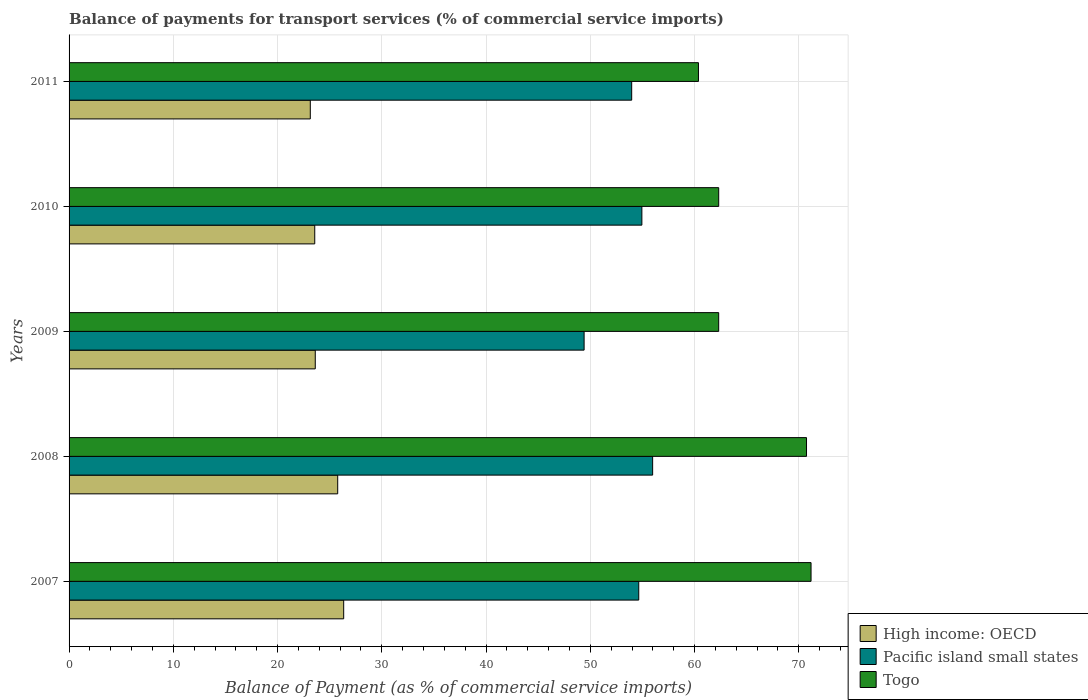How many different coloured bars are there?
Offer a very short reply. 3. Are the number of bars per tick equal to the number of legend labels?
Offer a very short reply. Yes. In how many cases, is the number of bars for a given year not equal to the number of legend labels?
Ensure brevity in your answer.  0. What is the balance of payments for transport services in Togo in 2009?
Your response must be concise. 62.31. Across all years, what is the maximum balance of payments for transport services in High income: OECD?
Make the answer very short. 26.34. Across all years, what is the minimum balance of payments for transport services in High income: OECD?
Provide a short and direct response. 23.14. In which year was the balance of payments for transport services in High income: OECD maximum?
Keep it short and to the point. 2007. In which year was the balance of payments for transport services in Togo minimum?
Make the answer very short. 2011. What is the total balance of payments for transport services in Togo in the graph?
Offer a terse response. 326.91. What is the difference between the balance of payments for transport services in Togo in 2008 and that in 2011?
Provide a succinct answer. 10.37. What is the difference between the balance of payments for transport services in Togo in 2009 and the balance of payments for transport services in Pacific island small states in 2007?
Make the answer very short. 7.67. What is the average balance of payments for transport services in High income: OECD per year?
Your answer should be very brief. 24.49. In the year 2008, what is the difference between the balance of payments for transport services in High income: OECD and balance of payments for transport services in Togo?
Provide a short and direct response. -44.97. What is the ratio of the balance of payments for transport services in Pacific island small states in 2008 to that in 2009?
Give a very brief answer. 1.13. Is the balance of payments for transport services in Pacific island small states in 2008 less than that in 2011?
Offer a very short reply. No. Is the difference between the balance of payments for transport services in High income: OECD in 2009 and 2010 greater than the difference between the balance of payments for transport services in Togo in 2009 and 2010?
Offer a terse response. Yes. What is the difference between the highest and the second highest balance of payments for transport services in Pacific island small states?
Offer a very short reply. 1.03. What is the difference between the highest and the lowest balance of payments for transport services in Togo?
Your answer should be compact. 10.8. In how many years, is the balance of payments for transport services in High income: OECD greater than the average balance of payments for transport services in High income: OECD taken over all years?
Keep it short and to the point. 2. What does the 1st bar from the top in 2008 represents?
Give a very brief answer. Togo. What does the 3rd bar from the bottom in 2007 represents?
Provide a short and direct response. Togo. Is it the case that in every year, the sum of the balance of payments for transport services in High income: OECD and balance of payments for transport services in Pacific island small states is greater than the balance of payments for transport services in Togo?
Offer a very short reply. Yes. How many bars are there?
Your response must be concise. 15. Are all the bars in the graph horizontal?
Give a very brief answer. Yes. Does the graph contain any zero values?
Provide a short and direct response. No. Where does the legend appear in the graph?
Your response must be concise. Bottom right. How many legend labels are there?
Offer a very short reply. 3. What is the title of the graph?
Your answer should be compact. Balance of payments for transport services (% of commercial service imports). What is the label or title of the X-axis?
Provide a short and direct response. Balance of Payment (as % of commercial service imports). What is the label or title of the Y-axis?
Your answer should be compact. Years. What is the Balance of Payment (as % of commercial service imports) in High income: OECD in 2007?
Keep it short and to the point. 26.34. What is the Balance of Payment (as % of commercial service imports) in Pacific island small states in 2007?
Ensure brevity in your answer.  54.64. What is the Balance of Payment (as % of commercial service imports) in Togo in 2007?
Provide a short and direct response. 71.17. What is the Balance of Payment (as % of commercial service imports) in High income: OECD in 2008?
Your answer should be compact. 25.77. What is the Balance of Payment (as % of commercial service imports) in Pacific island small states in 2008?
Your response must be concise. 55.98. What is the Balance of Payment (as % of commercial service imports) of Togo in 2008?
Offer a very short reply. 70.74. What is the Balance of Payment (as % of commercial service imports) of High income: OECD in 2009?
Ensure brevity in your answer.  23.62. What is the Balance of Payment (as % of commercial service imports) of Pacific island small states in 2009?
Ensure brevity in your answer.  49.4. What is the Balance of Payment (as % of commercial service imports) in Togo in 2009?
Your answer should be very brief. 62.31. What is the Balance of Payment (as % of commercial service imports) of High income: OECD in 2010?
Your response must be concise. 23.57. What is the Balance of Payment (as % of commercial service imports) of Pacific island small states in 2010?
Your response must be concise. 54.94. What is the Balance of Payment (as % of commercial service imports) of Togo in 2010?
Your answer should be compact. 62.31. What is the Balance of Payment (as % of commercial service imports) of High income: OECD in 2011?
Give a very brief answer. 23.14. What is the Balance of Payment (as % of commercial service imports) in Pacific island small states in 2011?
Your answer should be very brief. 53.97. What is the Balance of Payment (as % of commercial service imports) in Togo in 2011?
Your answer should be compact. 60.37. Across all years, what is the maximum Balance of Payment (as % of commercial service imports) of High income: OECD?
Your response must be concise. 26.34. Across all years, what is the maximum Balance of Payment (as % of commercial service imports) in Pacific island small states?
Provide a short and direct response. 55.98. Across all years, what is the maximum Balance of Payment (as % of commercial service imports) of Togo?
Provide a short and direct response. 71.17. Across all years, what is the minimum Balance of Payment (as % of commercial service imports) of High income: OECD?
Keep it short and to the point. 23.14. Across all years, what is the minimum Balance of Payment (as % of commercial service imports) of Pacific island small states?
Ensure brevity in your answer.  49.4. Across all years, what is the minimum Balance of Payment (as % of commercial service imports) in Togo?
Provide a short and direct response. 60.37. What is the total Balance of Payment (as % of commercial service imports) of High income: OECD in the graph?
Provide a succinct answer. 122.43. What is the total Balance of Payment (as % of commercial service imports) in Pacific island small states in the graph?
Make the answer very short. 268.93. What is the total Balance of Payment (as % of commercial service imports) in Togo in the graph?
Your response must be concise. 326.91. What is the difference between the Balance of Payment (as % of commercial service imports) in High income: OECD in 2007 and that in 2008?
Make the answer very short. 0.57. What is the difference between the Balance of Payment (as % of commercial service imports) of Pacific island small states in 2007 and that in 2008?
Provide a short and direct response. -1.33. What is the difference between the Balance of Payment (as % of commercial service imports) of Togo in 2007 and that in 2008?
Offer a terse response. 0.43. What is the difference between the Balance of Payment (as % of commercial service imports) of High income: OECD in 2007 and that in 2009?
Give a very brief answer. 2.73. What is the difference between the Balance of Payment (as % of commercial service imports) of Pacific island small states in 2007 and that in 2009?
Ensure brevity in your answer.  5.24. What is the difference between the Balance of Payment (as % of commercial service imports) in Togo in 2007 and that in 2009?
Keep it short and to the point. 8.86. What is the difference between the Balance of Payment (as % of commercial service imports) in High income: OECD in 2007 and that in 2010?
Your answer should be very brief. 2.77. What is the difference between the Balance of Payment (as % of commercial service imports) in Pacific island small states in 2007 and that in 2010?
Your response must be concise. -0.3. What is the difference between the Balance of Payment (as % of commercial service imports) in Togo in 2007 and that in 2010?
Your response must be concise. 8.86. What is the difference between the Balance of Payment (as % of commercial service imports) of High income: OECD in 2007 and that in 2011?
Keep it short and to the point. 3.2. What is the difference between the Balance of Payment (as % of commercial service imports) in Pacific island small states in 2007 and that in 2011?
Your answer should be compact. 0.68. What is the difference between the Balance of Payment (as % of commercial service imports) in Togo in 2007 and that in 2011?
Make the answer very short. 10.8. What is the difference between the Balance of Payment (as % of commercial service imports) in High income: OECD in 2008 and that in 2009?
Your answer should be very brief. 2.15. What is the difference between the Balance of Payment (as % of commercial service imports) in Pacific island small states in 2008 and that in 2009?
Provide a short and direct response. 6.57. What is the difference between the Balance of Payment (as % of commercial service imports) of Togo in 2008 and that in 2009?
Give a very brief answer. 8.42. What is the difference between the Balance of Payment (as % of commercial service imports) in High income: OECD in 2008 and that in 2010?
Make the answer very short. 2.2. What is the difference between the Balance of Payment (as % of commercial service imports) in Pacific island small states in 2008 and that in 2010?
Provide a short and direct response. 1.03. What is the difference between the Balance of Payment (as % of commercial service imports) of Togo in 2008 and that in 2010?
Keep it short and to the point. 8.42. What is the difference between the Balance of Payment (as % of commercial service imports) of High income: OECD in 2008 and that in 2011?
Provide a short and direct response. 2.63. What is the difference between the Balance of Payment (as % of commercial service imports) in Pacific island small states in 2008 and that in 2011?
Your answer should be very brief. 2.01. What is the difference between the Balance of Payment (as % of commercial service imports) of Togo in 2008 and that in 2011?
Offer a very short reply. 10.37. What is the difference between the Balance of Payment (as % of commercial service imports) of High income: OECD in 2009 and that in 2010?
Keep it short and to the point. 0.05. What is the difference between the Balance of Payment (as % of commercial service imports) in Pacific island small states in 2009 and that in 2010?
Keep it short and to the point. -5.54. What is the difference between the Balance of Payment (as % of commercial service imports) in Togo in 2009 and that in 2010?
Offer a very short reply. -0. What is the difference between the Balance of Payment (as % of commercial service imports) in High income: OECD in 2009 and that in 2011?
Provide a succinct answer. 0.48. What is the difference between the Balance of Payment (as % of commercial service imports) of Pacific island small states in 2009 and that in 2011?
Give a very brief answer. -4.56. What is the difference between the Balance of Payment (as % of commercial service imports) in Togo in 2009 and that in 2011?
Your response must be concise. 1.94. What is the difference between the Balance of Payment (as % of commercial service imports) in High income: OECD in 2010 and that in 2011?
Make the answer very short. 0.43. What is the difference between the Balance of Payment (as % of commercial service imports) of Pacific island small states in 2010 and that in 2011?
Your answer should be compact. 0.98. What is the difference between the Balance of Payment (as % of commercial service imports) in Togo in 2010 and that in 2011?
Ensure brevity in your answer.  1.94. What is the difference between the Balance of Payment (as % of commercial service imports) of High income: OECD in 2007 and the Balance of Payment (as % of commercial service imports) of Pacific island small states in 2008?
Keep it short and to the point. -29.64. What is the difference between the Balance of Payment (as % of commercial service imports) of High income: OECD in 2007 and the Balance of Payment (as % of commercial service imports) of Togo in 2008?
Keep it short and to the point. -44.4. What is the difference between the Balance of Payment (as % of commercial service imports) of Pacific island small states in 2007 and the Balance of Payment (as % of commercial service imports) of Togo in 2008?
Provide a short and direct response. -16.09. What is the difference between the Balance of Payment (as % of commercial service imports) of High income: OECD in 2007 and the Balance of Payment (as % of commercial service imports) of Pacific island small states in 2009?
Offer a very short reply. -23.06. What is the difference between the Balance of Payment (as % of commercial service imports) in High income: OECD in 2007 and the Balance of Payment (as % of commercial service imports) in Togo in 2009?
Ensure brevity in your answer.  -35.97. What is the difference between the Balance of Payment (as % of commercial service imports) in Pacific island small states in 2007 and the Balance of Payment (as % of commercial service imports) in Togo in 2009?
Make the answer very short. -7.67. What is the difference between the Balance of Payment (as % of commercial service imports) of High income: OECD in 2007 and the Balance of Payment (as % of commercial service imports) of Pacific island small states in 2010?
Give a very brief answer. -28.6. What is the difference between the Balance of Payment (as % of commercial service imports) in High income: OECD in 2007 and the Balance of Payment (as % of commercial service imports) in Togo in 2010?
Make the answer very short. -35.97. What is the difference between the Balance of Payment (as % of commercial service imports) in Pacific island small states in 2007 and the Balance of Payment (as % of commercial service imports) in Togo in 2010?
Ensure brevity in your answer.  -7.67. What is the difference between the Balance of Payment (as % of commercial service imports) of High income: OECD in 2007 and the Balance of Payment (as % of commercial service imports) of Pacific island small states in 2011?
Make the answer very short. -27.63. What is the difference between the Balance of Payment (as % of commercial service imports) in High income: OECD in 2007 and the Balance of Payment (as % of commercial service imports) in Togo in 2011?
Provide a short and direct response. -34.03. What is the difference between the Balance of Payment (as % of commercial service imports) of Pacific island small states in 2007 and the Balance of Payment (as % of commercial service imports) of Togo in 2011?
Your response must be concise. -5.73. What is the difference between the Balance of Payment (as % of commercial service imports) of High income: OECD in 2008 and the Balance of Payment (as % of commercial service imports) of Pacific island small states in 2009?
Offer a terse response. -23.64. What is the difference between the Balance of Payment (as % of commercial service imports) in High income: OECD in 2008 and the Balance of Payment (as % of commercial service imports) in Togo in 2009?
Your answer should be compact. -36.55. What is the difference between the Balance of Payment (as % of commercial service imports) of Pacific island small states in 2008 and the Balance of Payment (as % of commercial service imports) of Togo in 2009?
Your answer should be compact. -6.34. What is the difference between the Balance of Payment (as % of commercial service imports) in High income: OECD in 2008 and the Balance of Payment (as % of commercial service imports) in Pacific island small states in 2010?
Ensure brevity in your answer.  -29.18. What is the difference between the Balance of Payment (as % of commercial service imports) in High income: OECD in 2008 and the Balance of Payment (as % of commercial service imports) in Togo in 2010?
Your response must be concise. -36.55. What is the difference between the Balance of Payment (as % of commercial service imports) of Pacific island small states in 2008 and the Balance of Payment (as % of commercial service imports) of Togo in 2010?
Offer a very short reply. -6.34. What is the difference between the Balance of Payment (as % of commercial service imports) in High income: OECD in 2008 and the Balance of Payment (as % of commercial service imports) in Pacific island small states in 2011?
Offer a terse response. -28.2. What is the difference between the Balance of Payment (as % of commercial service imports) of High income: OECD in 2008 and the Balance of Payment (as % of commercial service imports) of Togo in 2011?
Keep it short and to the point. -34.6. What is the difference between the Balance of Payment (as % of commercial service imports) in Pacific island small states in 2008 and the Balance of Payment (as % of commercial service imports) in Togo in 2011?
Provide a succinct answer. -4.4. What is the difference between the Balance of Payment (as % of commercial service imports) of High income: OECD in 2009 and the Balance of Payment (as % of commercial service imports) of Pacific island small states in 2010?
Provide a succinct answer. -31.33. What is the difference between the Balance of Payment (as % of commercial service imports) of High income: OECD in 2009 and the Balance of Payment (as % of commercial service imports) of Togo in 2010?
Your answer should be compact. -38.7. What is the difference between the Balance of Payment (as % of commercial service imports) of Pacific island small states in 2009 and the Balance of Payment (as % of commercial service imports) of Togo in 2010?
Provide a short and direct response. -12.91. What is the difference between the Balance of Payment (as % of commercial service imports) of High income: OECD in 2009 and the Balance of Payment (as % of commercial service imports) of Pacific island small states in 2011?
Your response must be concise. -30.35. What is the difference between the Balance of Payment (as % of commercial service imports) in High income: OECD in 2009 and the Balance of Payment (as % of commercial service imports) in Togo in 2011?
Offer a very short reply. -36.76. What is the difference between the Balance of Payment (as % of commercial service imports) in Pacific island small states in 2009 and the Balance of Payment (as % of commercial service imports) in Togo in 2011?
Ensure brevity in your answer.  -10.97. What is the difference between the Balance of Payment (as % of commercial service imports) of High income: OECD in 2010 and the Balance of Payment (as % of commercial service imports) of Pacific island small states in 2011?
Provide a succinct answer. -30.4. What is the difference between the Balance of Payment (as % of commercial service imports) of High income: OECD in 2010 and the Balance of Payment (as % of commercial service imports) of Togo in 2011?
Offer a terse response. -36.81. What is the difference between the Balance of Payment (as % of commercial service imports) of Pacific island small states in 2010 and the Balance of Payment (as % of commercial service imports) of Togo in 2011?
Ensure brevity in your answer.  -5.43. What is the average Balance of Payment (as % of commercial service imports) of High income: OECD per year?
Ensure brevity in your answer.  24.49. What is the average Balance of Payment (as % of commercial service imports) in Pacific island small states per year?
Offer a very short reply. 53.79. What is the average Balance of Payment (as % of commercial service imports) of Togo per year?
Give a very brief answer. 65.38. In the year 2007, what is the difference between the Balance of Payment (as % of commercial service imports) in High income: OECD and Balance of Payment (as % of commercial service imports) in Pacific island small states?
Give a very brief answer. -28.3. In the year 2007, what is the difference between the Balance of Payment (as % of commercial service imports) of High income: OECD and Balance of Payment (as % of commercial service imports) of Togo?
Keep it short and to the point. -44.83. In the year 2007, what is the difference between the Balance of Payment (as % of commercial service imports) of Pacific island small states and Balance of Payment (as % of commercial service imports) of Togo?
Offer a terse response. -16.53. In the year 2008, what is the difference between the Balance of Payment (as % of commercial service imports) in High income: OECD and Balance of Payment (as % of commercial service imports) in Pacific island small states?
Give a very brief answer. -30.21. In the year 2008, what is the difference between the Balance of Payment (as % of commercial service imports) in High income: OECD and Balance of Payment (as % of commercial service imports) in Togo?
Provide a short and direct response. -44.97. In the year 2008, what is the difference between the Balance of Payment (as % of commercial service imports) in Pacific island small states and Balance of Payment (as % of commercial service imports) in Togo?
Offer a terse response. -14.76. In the year 2009, what is the difference between the Balance of Payment (as % of commercial service imports) in High income: OECD and Balance of Payment (as % of commercial service imports) in Pacific island small states?
Give a very brief answer. -25.79. In the year 2009, what is the difference between the Balance of Payment (as % of commercial service imports) of High income: OECD and Balance of Payment (as % of commercial service imports) of Togo?
Provide a short and direct response. -38.7. In the year 2009, what is the difference between the Balance of Payment (as % of commercial service imports) in Pacific island small states and Balance of Payment (as % of commercial service imports) in Togo?
Give a very brief answer. -12.91. In the year 2010, what is the difference between the Balance of Payment (as % of commercial service imports) of High income: OECD and Balance of Payment (as % of commercial service imports) of Pacific island small states?
Give a very brief answer. -31.38. In the year 2010, what is the difference between the Balance of Payment (as % of commercial service imports) of High income: OECD and Balance of Payment (as % of commercial service imports) of Togo?
Keep it short and to the point. -38.75. In the year 2010, what is the difference between the Balance of Payment (as % of commercial service imports) of Pacific island small states and Balance of Payment (as % of commercial service imports) of Togo?
Make the answer very short. -7.37. In the year 2011, what is the difference between the Balance of Payment (as % of commercial service imports) of High income: OECD and Balance of Payment (as % of commercial service imports) of Pacific island small states?
Your answer should be compact. -30.83. In the year 2011, what is the difference between the Balance of Payment (as % of commercial service imports) of High income: OECD and Balance of Payment (as % of commercial service imports) of Togo?
Offer a terse response. -37.23. In the year 2011, what is the difference between the Balance of Payment (as % of commercial service imports) of Pacific island small states and Balance of Payment (as % of commercial service imports) of Togo?
Provide a short and direct response. -6.4. What is the ratio of the Balance of Payment (as % of commercial service imports) in High income: OECD in 2007 to that in 2008?
Make the answer very short. 1.02. What is the ratio of the Balance of Payment (as % of commercial service imports) in Pacific island small states in 2007 to that in 2008?
Offer a very short reply. 0.98. What is the ratio of the Balance of Payment (as % of commercial service imports) in High income: OECD in 2007 to that in 2009?
Provide a succinct answer. 1.12. What is the ratio of the Balance of Payment (as % of commercial service imports) in Pacific island small states in 2007 to that in 2009?
Keep it short and to the point. 1.11. What is the ratio of the Balance of Payment (as % of commercial service imports) of Togo in 2007 to that in 2009?
Your answer should be compact. 1.14. What is the ratio of the Balance of Payment (as % of commercial service imports) of High income: OECD in 2007 to that in 2010?
Your response must be concise. 1.12. What is the ratio of the Balance of Payment (as % of commercial service imports) of Pacific island small states in 2007 to that in 2010?
Give a very brief answer. 0.99. What is the ratio of the Balance of Payment (as % of commercial service imports) of Togo in 2007 to that in 2010?
Keep it short and to the point. 1.14. What is the ratio of the Balance of Payment (as % of commercial service imports) in High income: OECD in 2007 to that in 2011?
Ensure brevity in your answer.  1.14. What is the ratio of the Balance of Payment (as % of commercial service imports) in Pacific island small states in 2007 to that in 2011?
Your answer should be very brief. 1.01. What is the ratio of the Balance of Payment (as % of commercial service imports) in Togo in 2007 to that in 2011?
Make the answer very short. 1.18. What is the ratio of the Balance of Payment (as % of commercial service imports) of High income: OECD in 2008 to that in 2009?
Provide a succinct answer. 1.09. What is the ratio of the Balance of Payment (as % of commercial service imports) of Pacific island small states in 2008 to that in 2009?
Your response must be concise. 1.13. What is the ratio of the Balance of Payment (as % of commercial service imports) in Togo in 2008 to that in 2009?
Provide a short and direct response. 1.14. What is the ratio of the Balance of Payment (as % of commercial service imports) of High income: OECD in 2008 to that in 2010?
Your response must be concise. 1.09. What is the ratio of the Balance of Payment (as % of commercial service imports) of Pacific island small states in 2008 to that in 2010?
Your response must be concise. 1.02. What is the ratio of the Balance of Payment (as % of commercial service imports) of Togo in 2008 to that in 2010?
Ensure brevity in your answer.  1.14. What is the ratio of the Balance of Payment (as % of commercial service imports) in High income: OECD in 2008 to that in 2011?
Your response must be concise. 1.11. What is the ratio of the Balance of Payment (as % of commercial service imports) of Pacific island small states in 2008 to that in 2011?
Your response must be concise. 1.04. What is the ratio of the Balance of Payment (as % of commercial service imports) in Togo in 2008 to that in 2011?
Make the answer very short. 1.17. What is the ratio of the Balance of Payment (as % of commercial service imports) of High income: OECD in 2009 to that in 2010?
Keep it short and to the point. 1. What is the ratio of the Balance of Payment (as % of commercial service imports) in Pacific island small states in 2009 to that in 2010?
Your response must be concise. 0.9. What is the ratio of the Balance of Payment (as % of commercial service imports) of High income: OECD in 2009 to that in 2011?
Offer a terse response. 1.02. What is the ratio of the Balance of Payment (as % of commercial service imports) of Pacific island small states in 2009 to that in 2011?
Provide a succinct answer. 0.92. What is the ratio of the Balance of Payment (as % of commercial service imports) of Togo in 2009 to that in 2011?
Give a very brief answer. 1.03. What is the ratio of the Balance of Payment (as % of commercial service imports) of High income: OECD in 2010 to that in 2011?
Ensure brevity in your answer.  1.02. What is the ratio of the Balance of Payment (as % of commercial service imports) of Pacific island small states in 2010 to that in 2011?
Give a very brief answer. 1.02. What is the ratio of the Balance of Payment (as % of commercial service imports) in Togo in 2010 to that in 2011?
Offer a very short reply. 1.03. What is the difference between the highest and the second highest Balance of Payment (as % of commercial service imports) of High income: OECD?
Provide a succinct answer. 0.57. What is the difference between the highest and the second highest Balance of Payment (as % of commercial service imports) in Pacific island small states?
Provide a short and direct response. 1.03. What is the difference between the highest and the second highest Balance of Payment (as % of commercial service imports) in Togo?
Offer a terse response. 0.43. What is the difference between the highest and the lowest Balance of Payment (as % of commercial service imports) in High income: OECD?
Offer a terse response. 3.2. What is the difference between the highest and the lowest Balance of Payment (as % of commercial service imports) in Pacific island small states?
Make the answer very short. 6.57. 